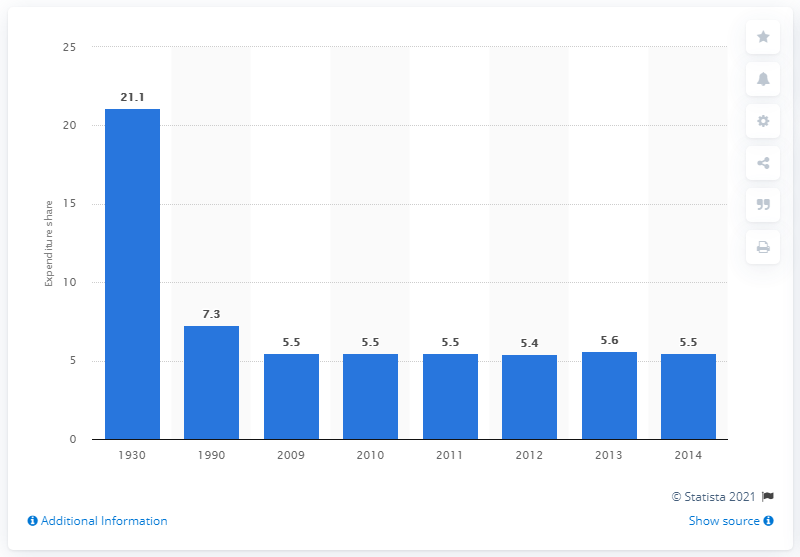Outline some significant characteristics in this image. In 2014, consumers spent an average of 5.5% of their disposable income on food at home, according to data. 